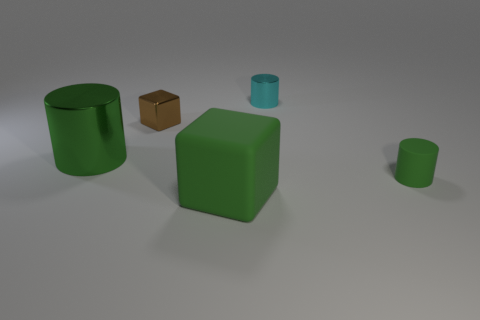Subtract all brown cylinders. Subtract all purple spheres. How many cylinders are left? 3 Add 2 small metal cylinders. How many objects exist? 7 Subtract all blocks. How many objects are left? 3 Subtract 0 purple balls. How many objects are left? 5 Subtract all small cyan cylinders. Subtract all tiny green cylinders. How many objects are left? 3 Add 5 tiny cyan cylinders. How many tiny cyan cylinders are left? 6 Add 4 large yellow metal balls. How many large yellow metal balls exist? 4 